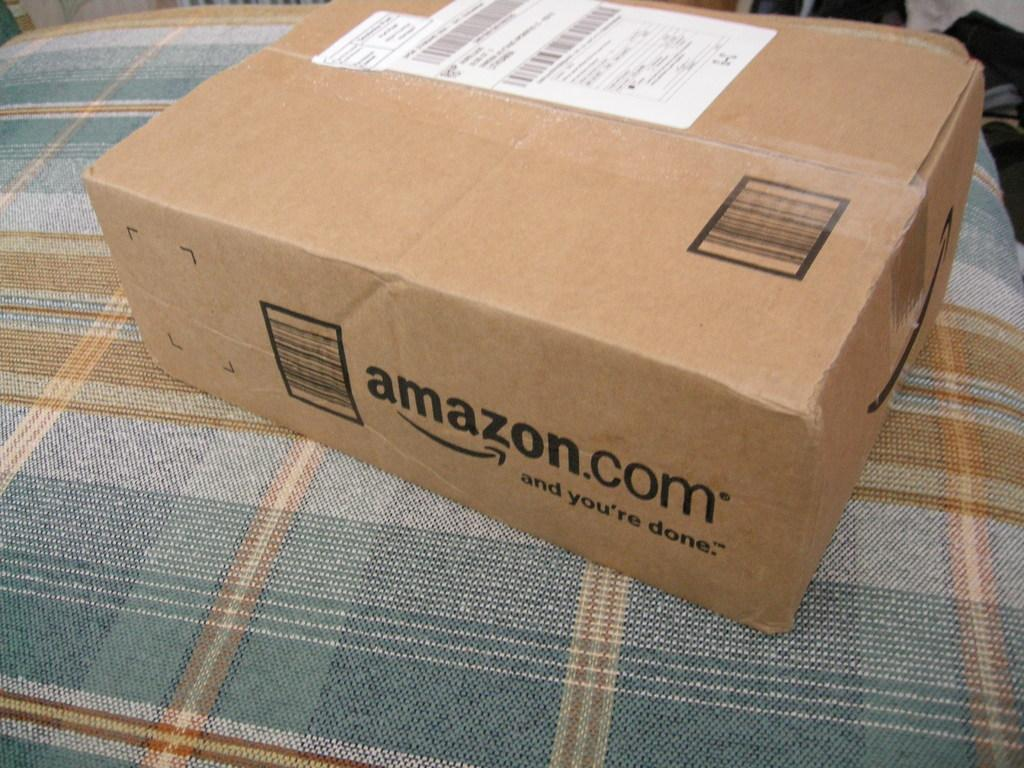<image>
Render a clear and concise summary of the photo. Cardboard box with a shipping label with lettering on the box of Amazon.com and you're done. 